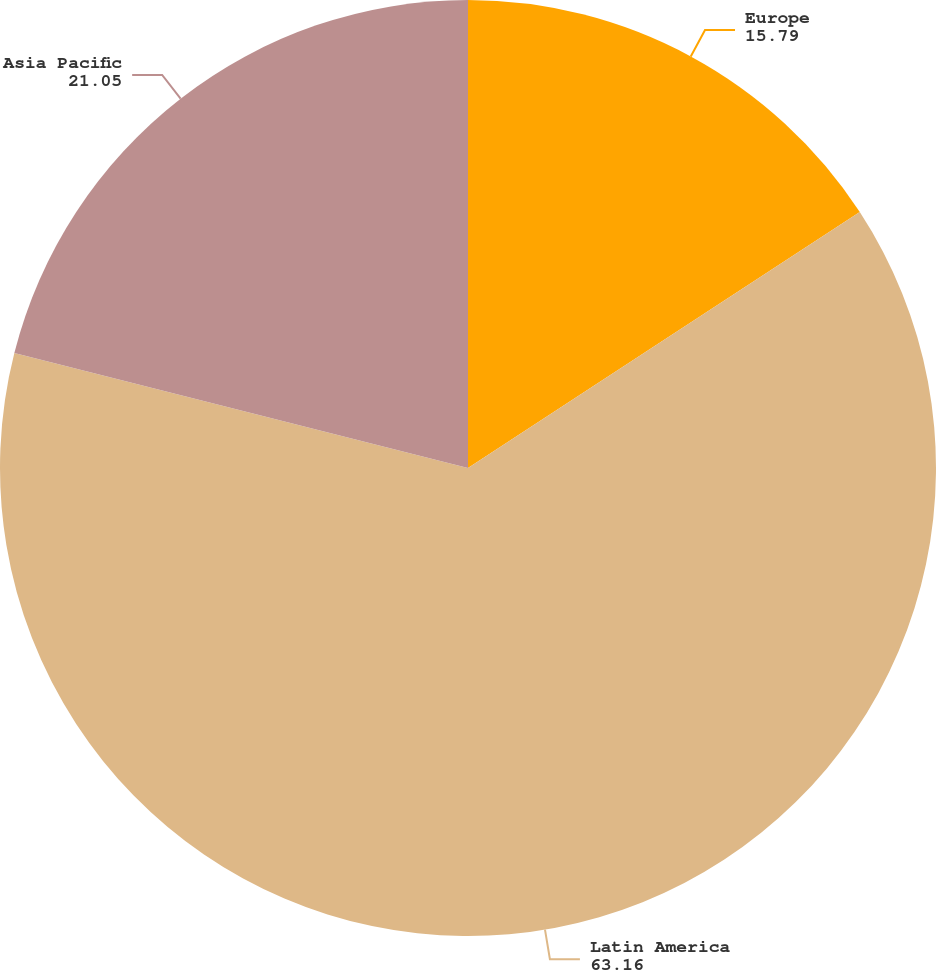<chart> <loc_0><loc_0><loc_500><loc_500><pie_chart><fcel>Europe<fcel>Latin America<fcel>Asia Pacific<nl><fcel>15.79%<fcel>63.16%<fcel>21.05%<nl></chart> 